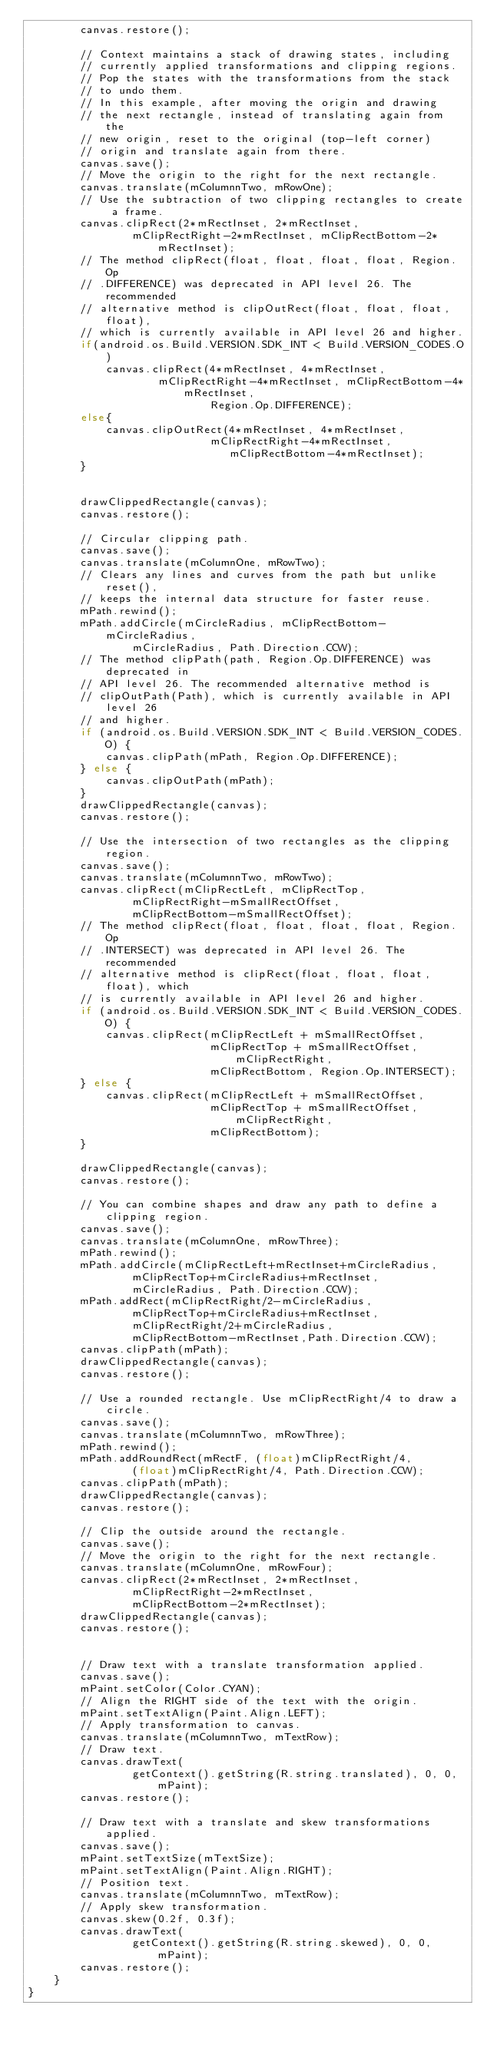Convert code to text. <code><loc_0><loc_0><loc_500><loc_500><_Java_>        canvas.restore();

        // Context maintains a stack of drawing states, including
        // currently applied transformations and clipping regions.
        // Pop the states with the transformations from the stack
        // to undo them.
        // In this example, after moving the origin and drawing
        // the next rectangle, instead of translating again from the
        // new origin, reset to the original (top-left corner)
        // origin and translate again from there.
        canvas.save();
        // Move the origin to the right for the next rectangle.
        canvas.translate(mColumnnTwo, mRowOne);
        // Use the subtraction of two clipping rectangles to create a frame.
        canvas.clipRect(2*mRectInset, 2*mRectInset,
                mClipRectRight-2*mRectInset, mClipRectBottom-2*mRectInset);
		// The method clipRect(float, float, float, float, Region.Op
        // .DIFFERENCE) was deprecated in API level 26. The recommended
        // alternative method is clipOutRect(float, float, float, float),
        // which is currently available in API level 26 and higher.
        if(android.os.Build.VERSION.SDK_INT < Build.VERSION_CODES.O)
            canvas.clipRect(4*mRectInset, 4*mRectInset,
                    mClipRectRight-4*mRectInset, mClipRectBottom-4*mRectInset,
                            Region.Op.DIFFERENCE);
        else{
            canvas.clipOutRect(4*mRectInset, 4*mRectInset,
                            mClipRectRight-4*mRectInset,
                               mClipRectBottom-4*mRectInset);
        }


        drawClippedRectangle(canvas);
        canvas.restore();

        // Circular clipping path.
        canvas.save();
        canvas.translate(mColumnOne, mRowTwo);
        // Clears any lines and curves from the path but unlike reset(),
        // keeps the internal data structure for faster reuse.
        mPath.rewind();
        mPath.addCircle(mCircleRadius, mClipRectBottom-mCircleRadius,
                mCircleRadius, Path.Direction.CCW);
        // The method clipPath(path, Region.Op.DIFFERENCE) was deprecated in
        // API level 26. The recommended alternative method is
        // clipOutPath(Path), which is currently available in API level 26
        // and higher.
        if (android.os.Build.VERSION.SDK_INT < Build.VERSION_CODES.O) {
            canvas.clipPath(mPath, Region.Op.DIFFERENCE);
        } else {
            canvas.clipOutPath(mPath);
        }
        drawClippedRectangle(canvas);
        canvas.restore();

        // Use the intersection of two rectangles as the clipping region.
        canvas.save();
        canvas.translate(mColumnnTwo, mRowTwo);
        canvas.clipRect(mClipRectLeft, mClipRectTop,
                mClipRectRight-mSmallRectOffset,
                mClipRectBottom-mSmallRectOffset);
        // The method clipRect(float, float, float, float, Region.Op
        // .INTERSECT) was deprecated in API level 26. The recommended
        // alternative method is clipRect(float, float, float, float), which
        // is currently available in API level 26 and higher.
        if (android.os.Build.VERSION.SDK_INT < Build.VERSION_CODES.O) {
            canvas.clipRect(mClipRectLeft + mSmallRectOffset,
                            mClipRectTop + mSmallRectOffset, mClipRectRight,
                            mClipRectBottom, Region.Op.INTERSECT);
        } else {
            canvas.clipRect(mClipRectLeft + mSmallRectOffset,
                            mClipRectTop + mSmallRectOffset, mClipRectRight,
                            mClipRectBottom);
        }

        drawClippedRectangle(canvas);
        canvas.restore();

        // You can combine shapes and draw any path to define a clipping region.
        canvas.save();
        canvas.translate(mColumnOne, mRowThree);
        mPath.rewind();
        mPath.addCircle(mClipRectLeft+mRectInset+mCircleRadius,
                mClipRectTop+mCircleRadius+mRectInset,
                mCircleRadius, Path.Direction.CCW);
        mPath.addRect(mClipRectRight/2-mCircleRadius,
                mClipRectTop+mCircleRadius+mRectInset,
                mClipRectRight/2+mCircleRadius,
                mClipRectBottom-mRectInset,Path.Direction.CCW);
        canvas.clipPath(mPath);
        drawClippedRectangle(canvas);
        canvas.restore();

        // Use a rounded rectangle. Use mClipRectRight/4 to draw a circle.
        canvas.save();
        canvas.translate(mColumnnTwo, mRowThree);
        mPath.rewind();
        mPath.addRoundRect(mRectF, (float)mClipRectRight/4,
                (float)mClipRectRight/4, Path.Direction.CCW);
        canvas.clipPath(mPath);
        drawClippedRectangle(canvas);
        canvas.restore();

        // Clip the outside around the rectangle.
        canvas.save();
        // Move the origin to the right for the next rectangle.
        canvas.translate(mColumnOne, mRowFour);
        canvas.clipRect(2*mRectInset, 2*mRectInset,
                mClipRectRight-2*mRectInset,
                mClipRectBottom-2*mRectInset);
        drawClippedRectangle(canvas);
        canvas.restore();


        // Draw text with a translate transformation applied.
        canvas.save();
        mPaint.setColor(Color.CYAN);
        // Align the RIGHT side of the text with the origin.
        mPaint.setTextAlign(Paint.Align.LEFT);
        // Apply transformation to canvas.
        canvas.translate(mColumnnTwo, mTextRow);
        // Draw text.
        canvas.drawText(
                getContext().getString(R.string.translated), 0, 0, mPaint);
        canvas.restore();

        // Draw text with a translate and skew transformations applied.
        canvas.save();
        mPaint.setTextSize(mTextSize);
        mPaint.setTextAlign(Paint.Align.RIGHT);
        // Position text.
        canvas.translate(mColumnnTwo, mTextRow);
        // Apply skew transformation.
        canvas.skew(0.2f, 0.3f);
        canvas.drawText(
                getContext().getString(R.string.skewed), 0, 0, mPaint);
        canvas.restore();
    }
}</code> 